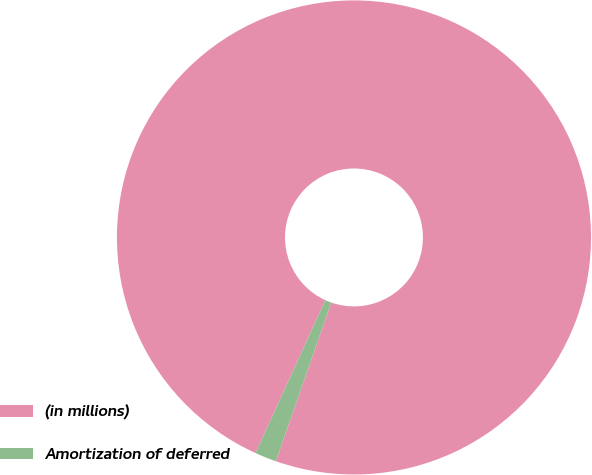<chart> <loc_0><loc_0><loc_500><loc_500><pie_chart><fcel>(in millions)<fcel>Amortization of deferred<nl><fcel>98.53%<fcel>1.47%<nl></chart> 